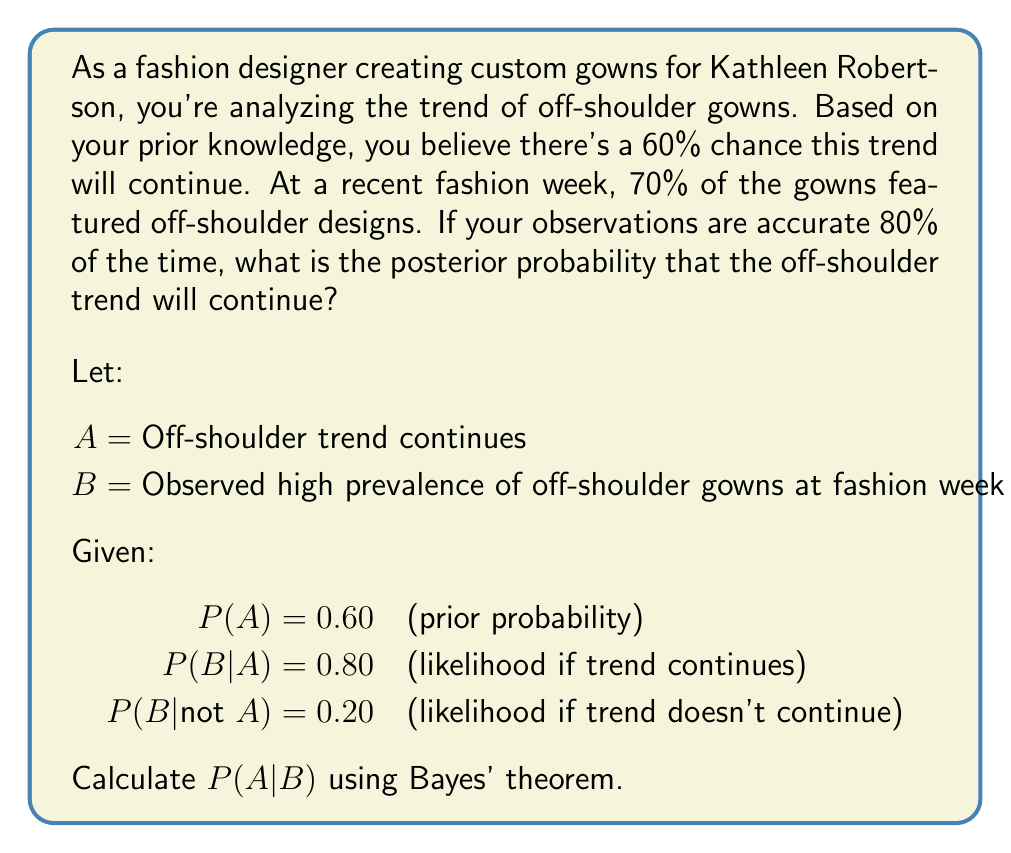What is the answer to this math problem? To solve this problem, we'll use Bayes' theorem:

$$ P(A|B) = \frac{P(B|A) \cdot P(A)}{P(B)} $$

1. We're given P(A) = 0.60 and P(B|A) = 0.80

2. We need to calculate P(B) using the law of total probability:
   $$ P(B) = P(B|A) \cdot P(A) + P(B|not A) \cdot P(not A) $$
   $$ P(B) = 0.80 \cdot 0.60 + 0.20 \cdot 0.40 $$
   $$ P(B) = 0.48 + 0.08 = 0.56 $$

3. Now we can apply Bayes' theorem:
   $$ P(A|B) = \frac{0.80 \cdot 0.60}{0.56} $$
   $$ P(A|B) = \frac{0.48}{0.56} $$
   $$ P(A|B) = 0.8571428571 $$

4. Converting to a percentage:
   $$ P(A|B) \approx 85.71\% $$

Therefore, the posterior probability that the off-shoulder trend will continue, given the observed data, is approximately 85.71%.
Answer: 85.71% 